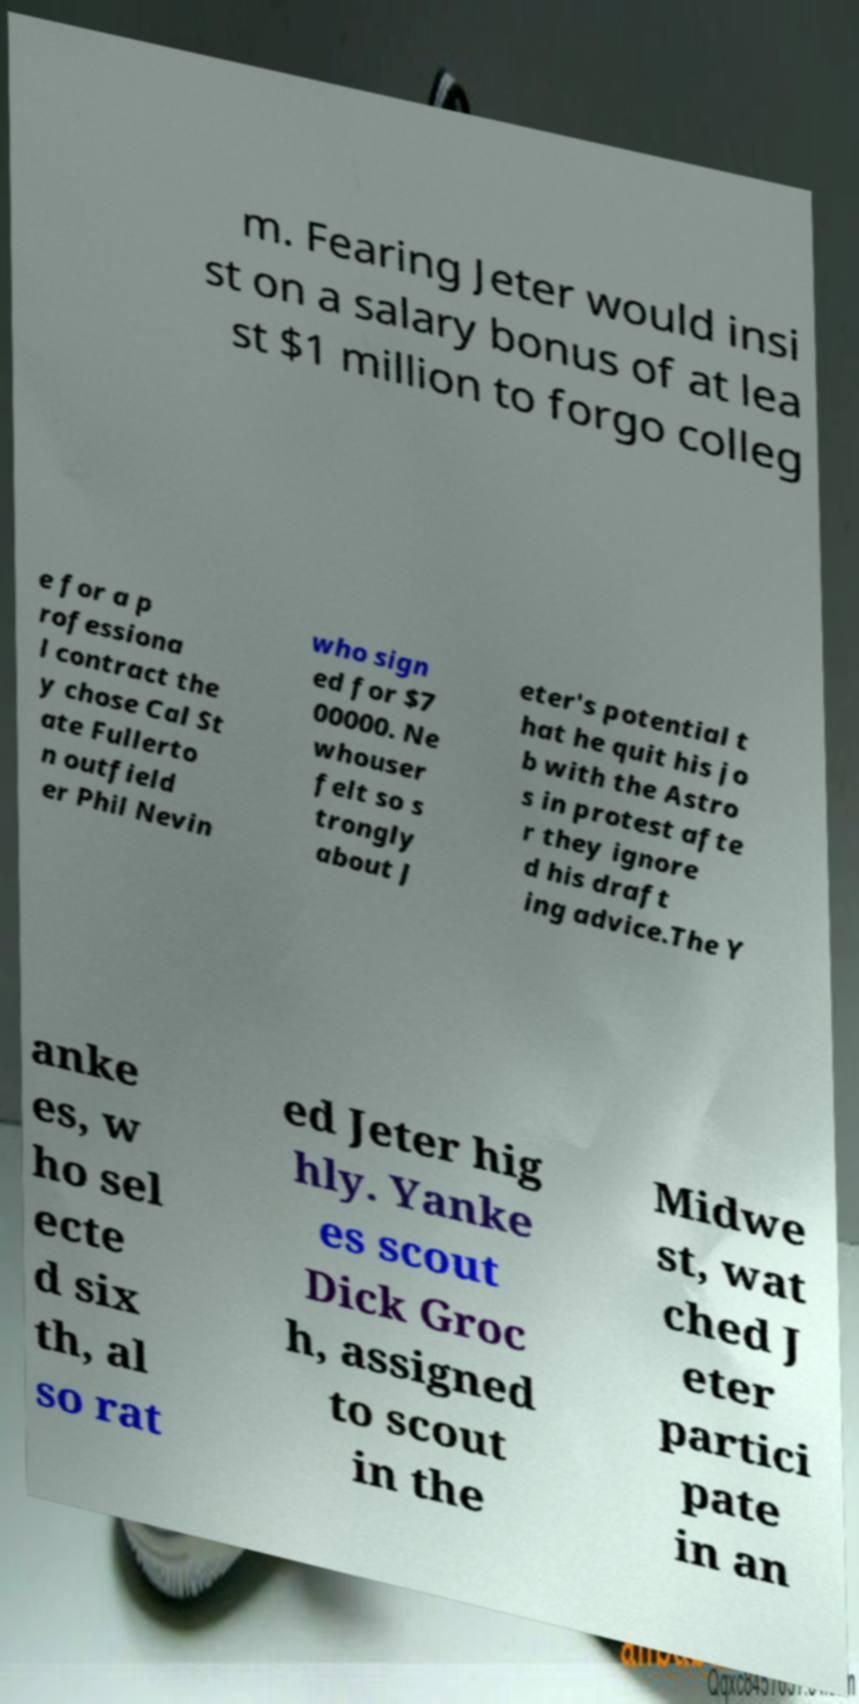For documentation purposes, I need the text within this image transcribed. Could you provide that? m. Fearing Jeter would insi st on a salary bonus of at lea st $1 million to forgo colleg e for a p rofessiona l contract the y chose Cal St ate Fullerto n outfield er Phil Nevin who sign ed for $7 00000. Ne whouser felt so s trongly about J eter's potential t hat he quit his jo b with the Astro s in protest afte r they ignore d his draft ing advice.The Y anke es, w ho sel ecte d six th, al so rat ed Jeter hig hly. Yanke es scout Dick Groc h, assigned to scout in the Midwe st, wat ched J eter partici pate in an 